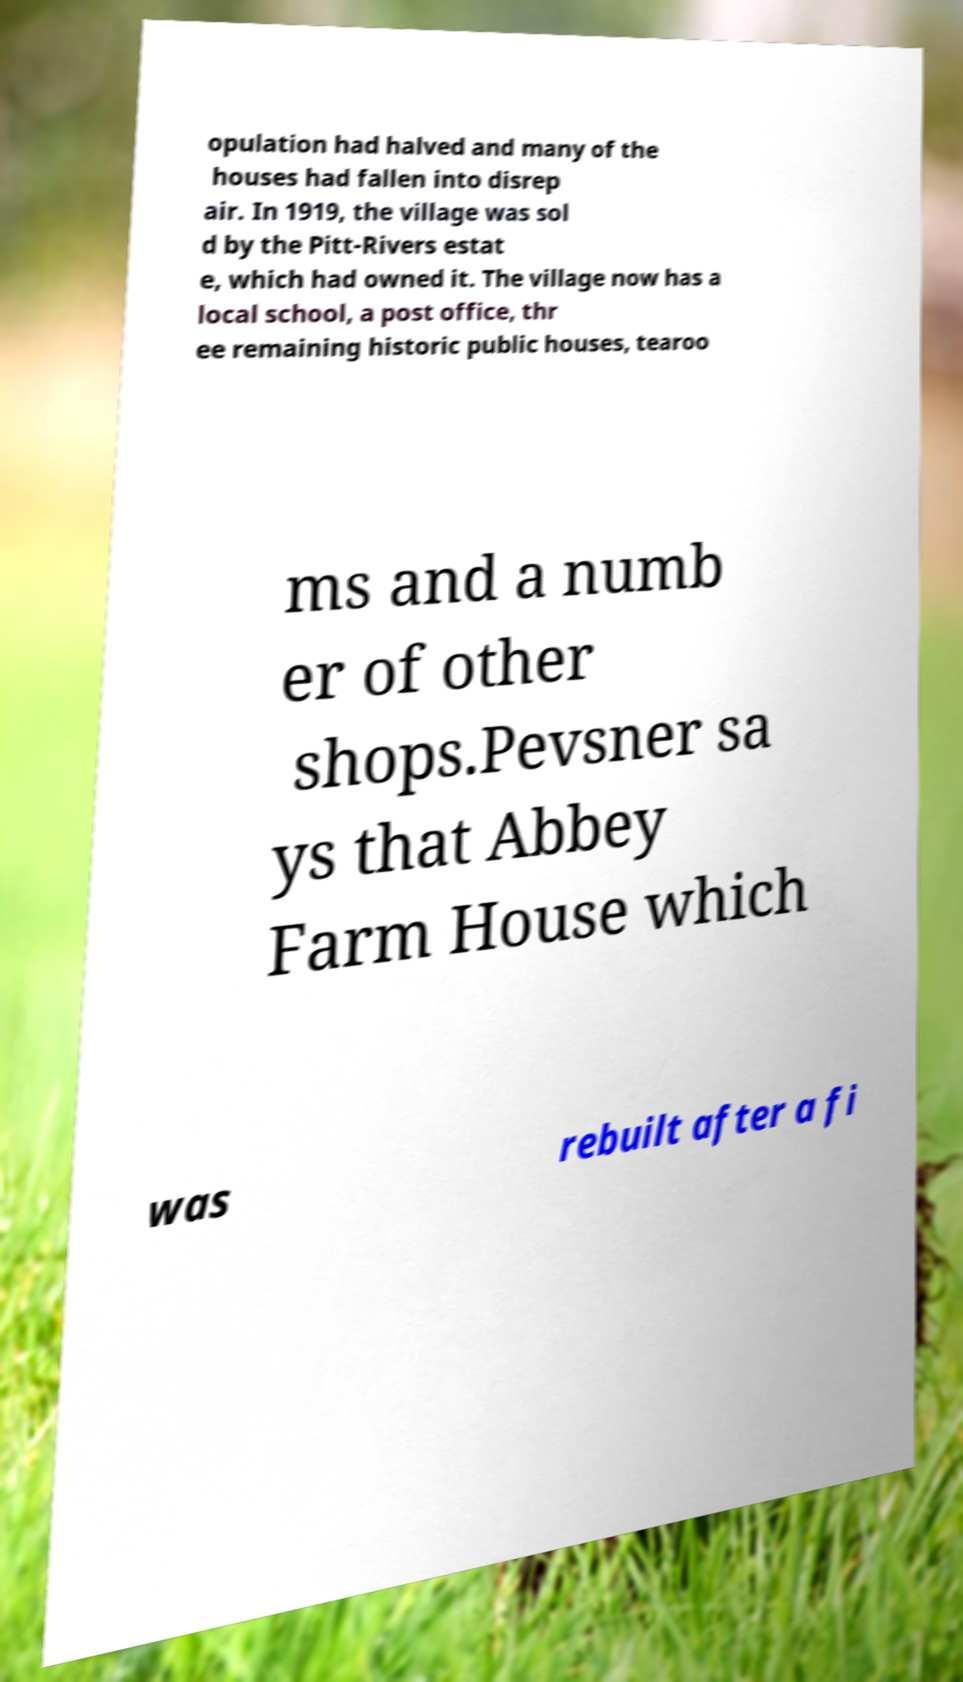I need the written content from this picture converted into text. Can you do that? opulation had halved and many of the houses had fallen into disrep air. In 1919, the village was sol d by the Pitt-Rivers estat e, which had owned it. The village now has a local school, a post office, thr ee remaining historic public houses, tearoo ms and a numb er of other shops.Pevsner sa ys that Abbey Farm House which was rebuilt after a fi 